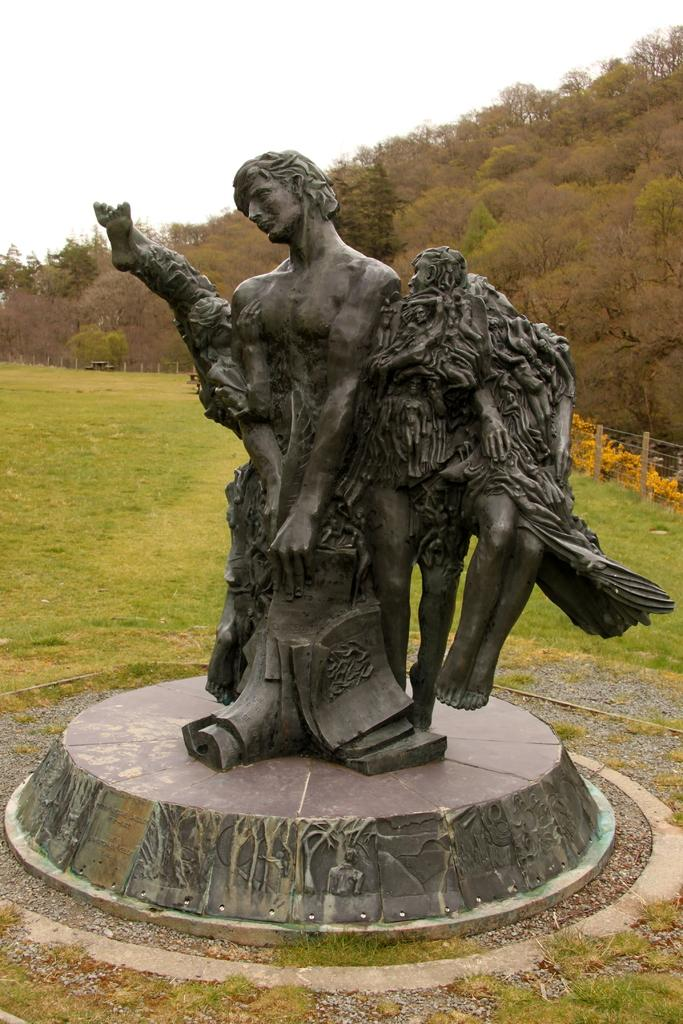What is the main subject in the middle of the image? There is a statue in the middle of the image. What type of terrain is visible behind the statue? There is grassland behind the statue. What can be seen on the right side of the image? There is a hill with trees on the right side of the image. What is visible above the hill in the image? The sky is visible above the hill. Can you tell me how many geese are swimming in the pond near the statue? There is no pond or geese present in the image; it features a statue, grassland, a hill with trees, and the sky. 